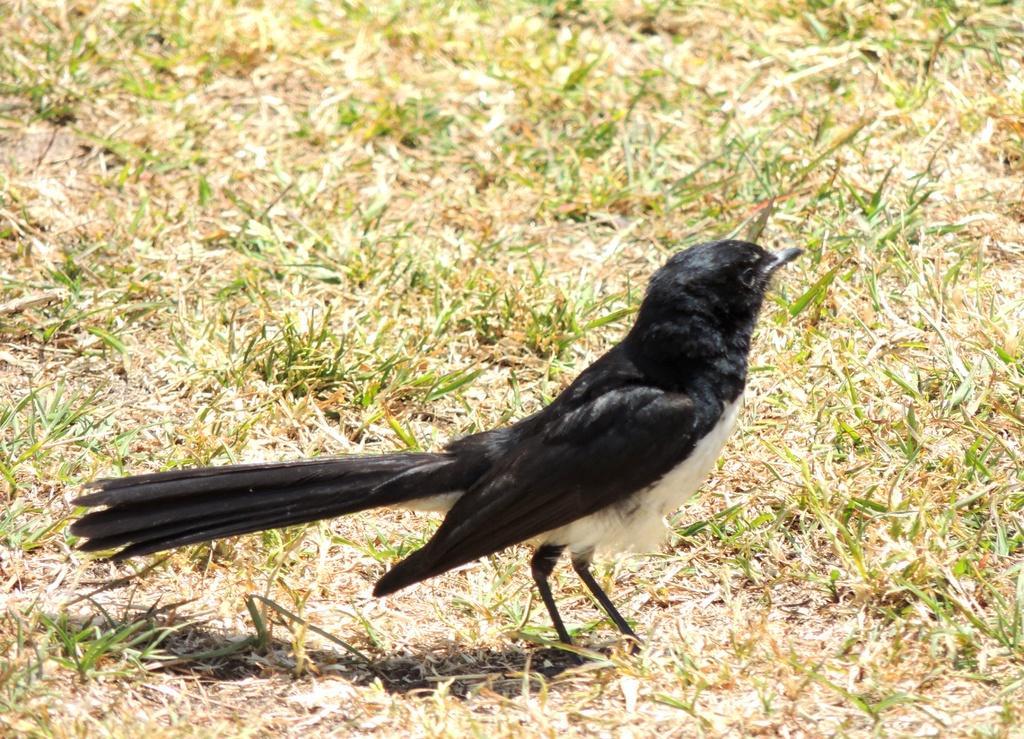Could you give a brief overview of what you see in this image? In the image there is a black color bird standing on the grassland. 